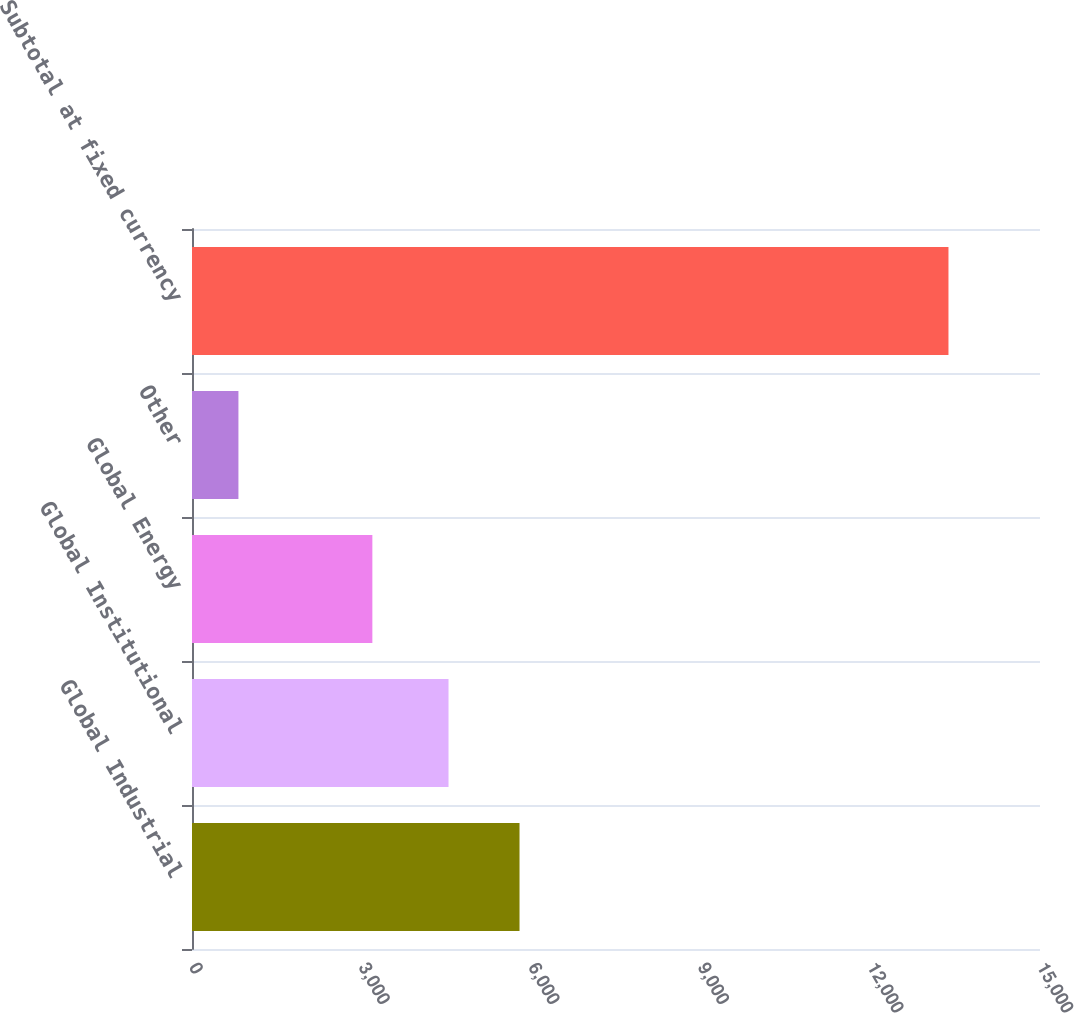Convert chart. <chart><loc_0><loc_0><loc_500><loc_500><bar_chart><fcel>Global Industrial<fcel>Global Institutional<fcel>Global Energy<fcel>Other<fcel>Subtotal at fixed currency<nl><fcel>5793.46<fcel>4537.5<fcel>3190.3<fcel>821.4<fcel>13381<nl></chart> 